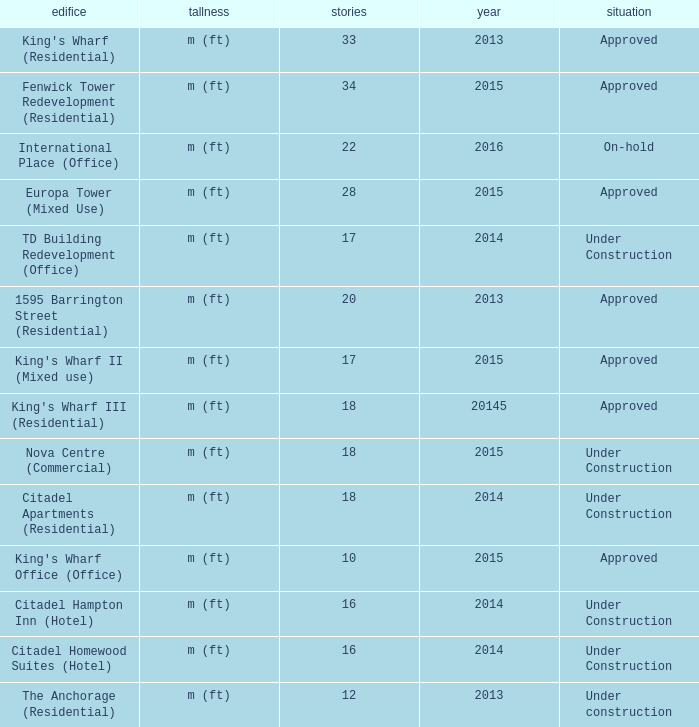What is the status of the building with more than 28 floor and a year of 2013? Approved. 